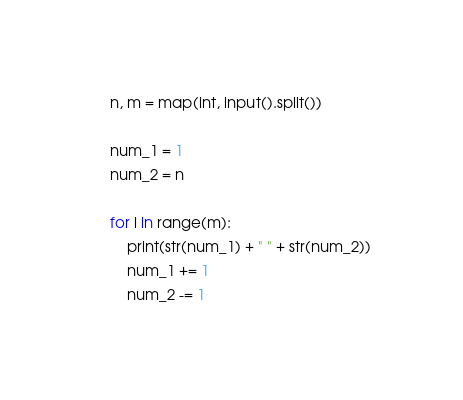Convert code to text. <code><loc_0><loc_0><loc_500><loc_500><_Python_>n, m = map(int, input().split())

num_1 = 1
num_2 = n

for i in range(m):
    print(str(num_1) + " " + str(num_2))
    num_1 += 1
    num_2 -= 1</code> 